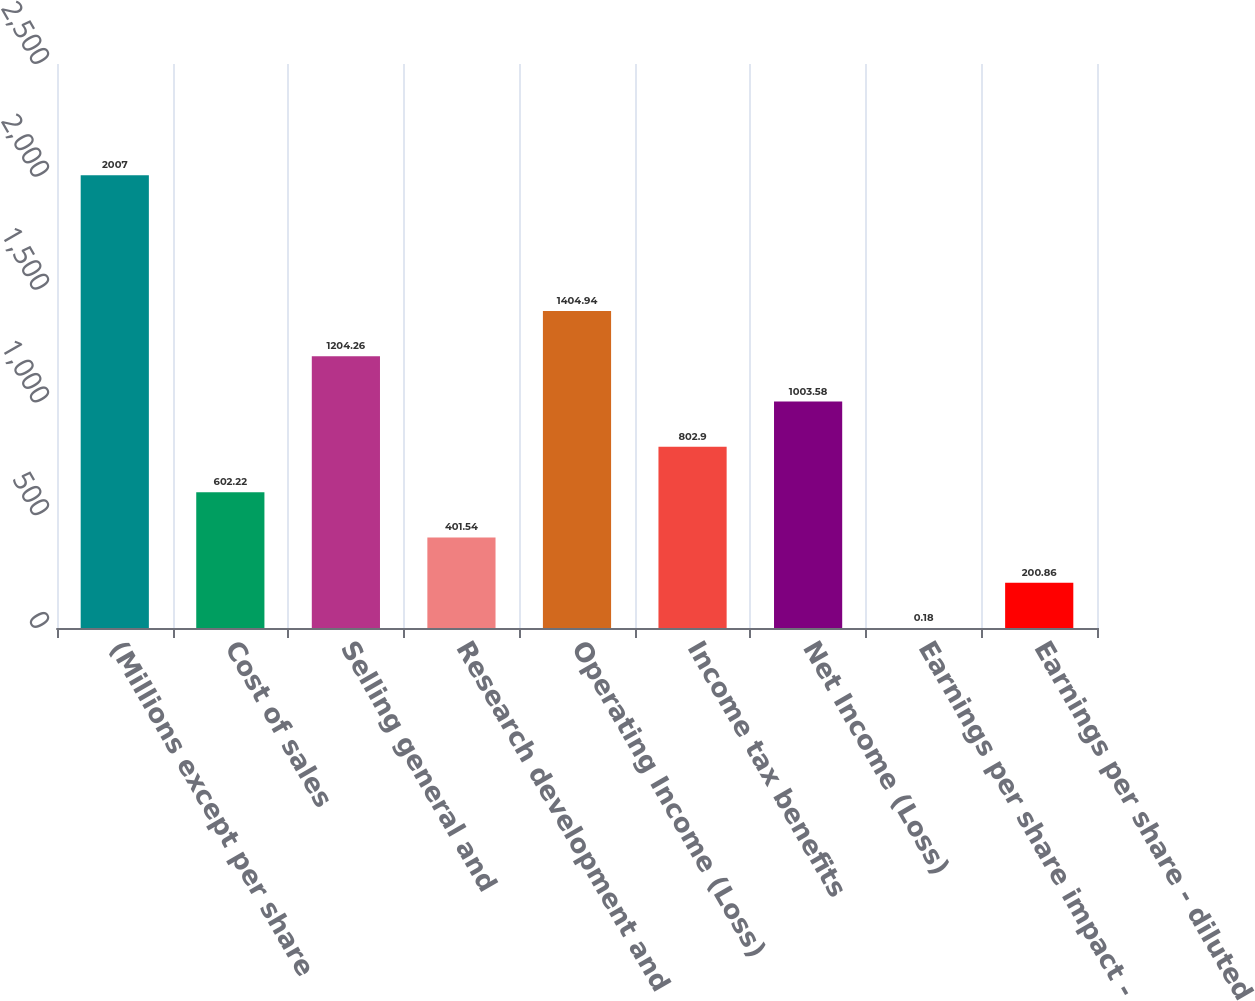<chart> <loc_0><loc_0><loc_500><loc_500><bar_chart><fcel>(Millions except per share<fcel>Cost of sales<fcel>Selling general and<fcel>Research development and<fcel>Operating Income (Loss)<fcel>Income tax benefits<fcel>Net Income (Loss)<fcel>Earnings per share impact -<fcel>Earnings per share - diluted<nl><fcel>2007<fcel>602.22<fcel>1204.26<fcel>401.54<fcel>1404.94<fcel>802.9<fcel>1003.58<fcel>0.18<fcel>200.86<nl></chart> 